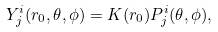Convert formula to latex. <formula><loc_0><loc_0><loc_500><loc_500>Y ^ { i } _ { j } ( r _ { 0 } , \theta , \phi ) = K ( r _ { 0 } ) P ^ { i } _ { j } ( \theta , \phi ) ,</formula> 